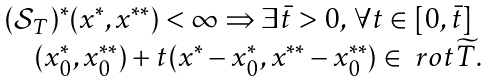Convert formula to latex. <formula><loc_0><loc_0><loc_500><loc_500>\begin{array} { l } ( \mathcal { S } _ { T } ) ^ { * } ( x ^ { * } , x ^ { * * } ) < \infty \Rightarrow \exists \bar { t } > 0 , \, \forall t \in [ 0 , \bar { t } ] \\ \quad ( x _ { 0 } ^ { * } , x _ { 0 } ^ { * * } ) + t ( x ^ { * } - x _ { 0 } ^ { * } , x ^ { * * } - x _ { 0 } ^ { * * } ) \in \ r o t \widetilde { T } . \end{array}</formula> 